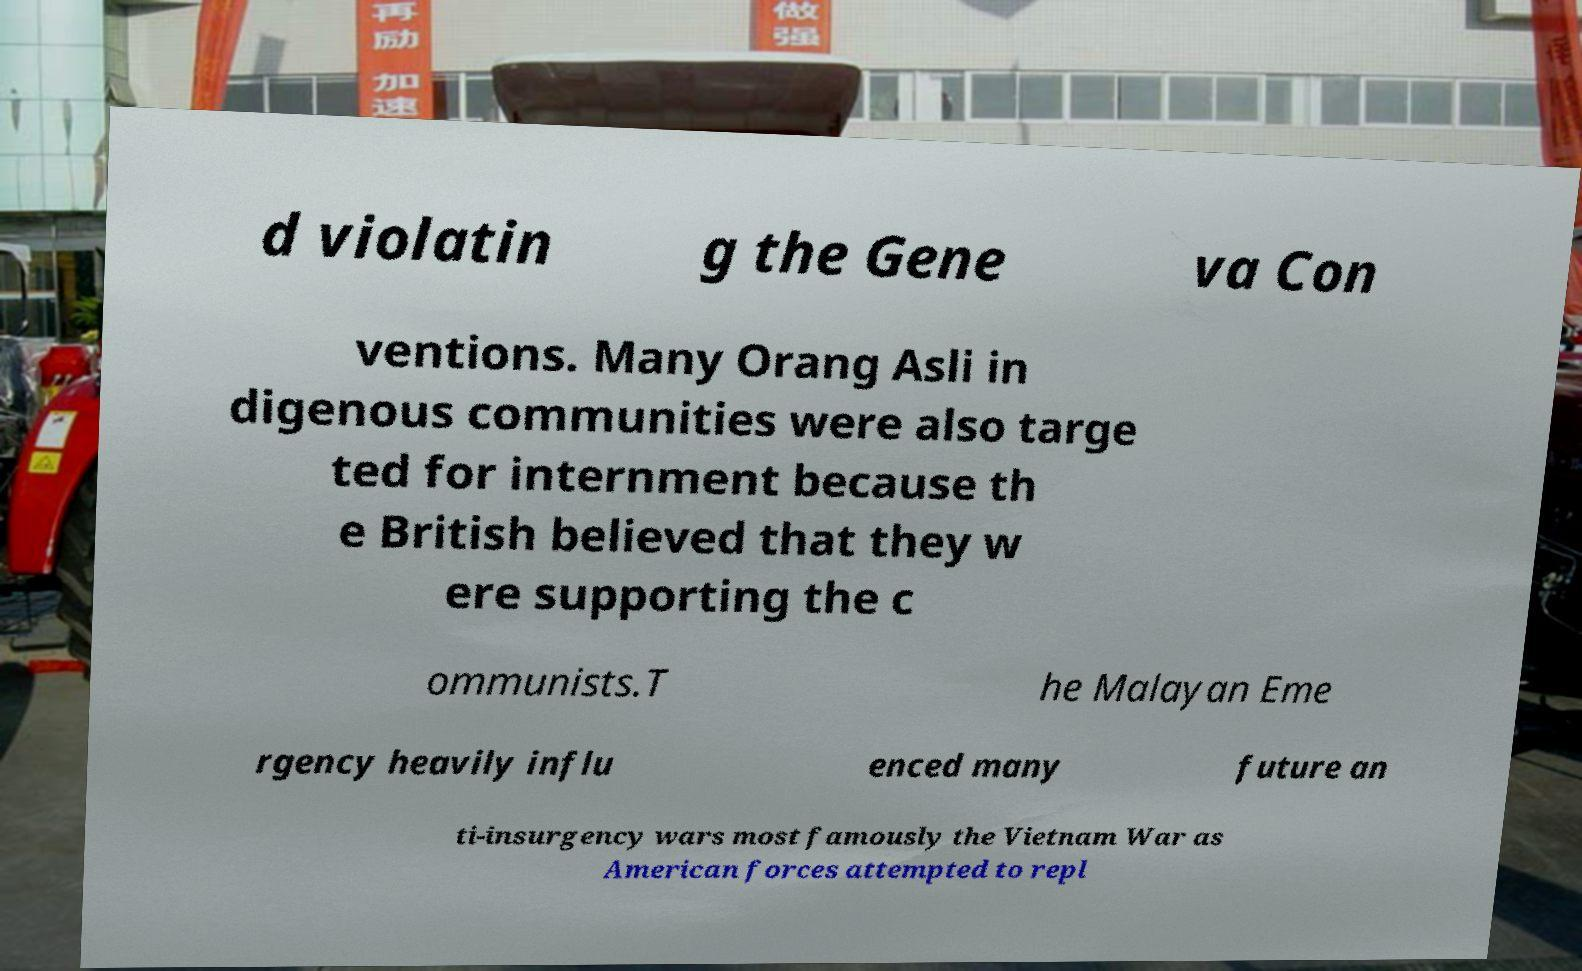I need the written content from this picture converted into text. Can you do that? d violatin g the Gene va Con ventions. Many Orang Asli in digenous communities were also targe ted for internment because th e British believed that they w ere supporting the c ommunists.T he Malayan Eme rgency heavily influ enced many future an ti-insurgency wars most famously the Vietnam War as American forces attempted to repl 